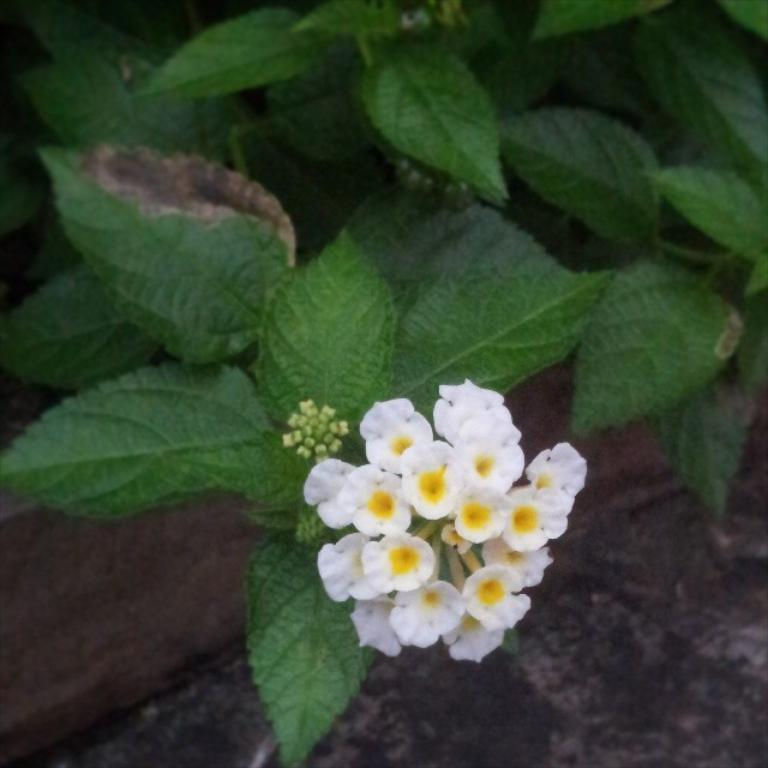What type of flowers are in the image? There are white-colored flowers in the image. What color are the leaves in the image? There are green-colored leaves in the image. What type of polish is being used by the friends in the image? There are no friends or any polish present in the image; it only features white-colored flowers and green-colored leaves. 